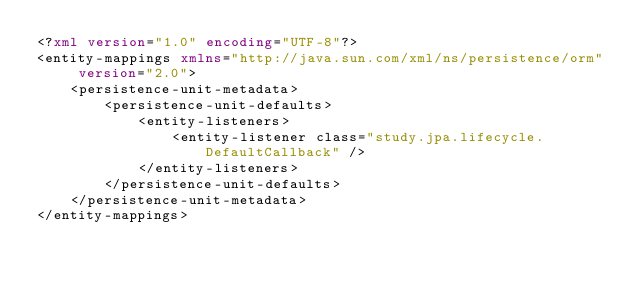<code> <loc_0><loc_0><loc_500><loc_500><_XML_><?xml version="1.0" encoding="UTF-8"?>
<entity-mappings xmlns="http://java.sun.com/xml/ns/persistence/orm" version="2.0">
	<persistence-unit-metadata>
		<persistence-unit-defaults>
			<entity-listeners>
				<entity-listener class="study.jpa.lifecycle.DefaultCallback" />
			</entity-listeners>
		</persistence-unit-defaults>
	</persistence-unit-metadata>
</entity-mappings>
</code> 